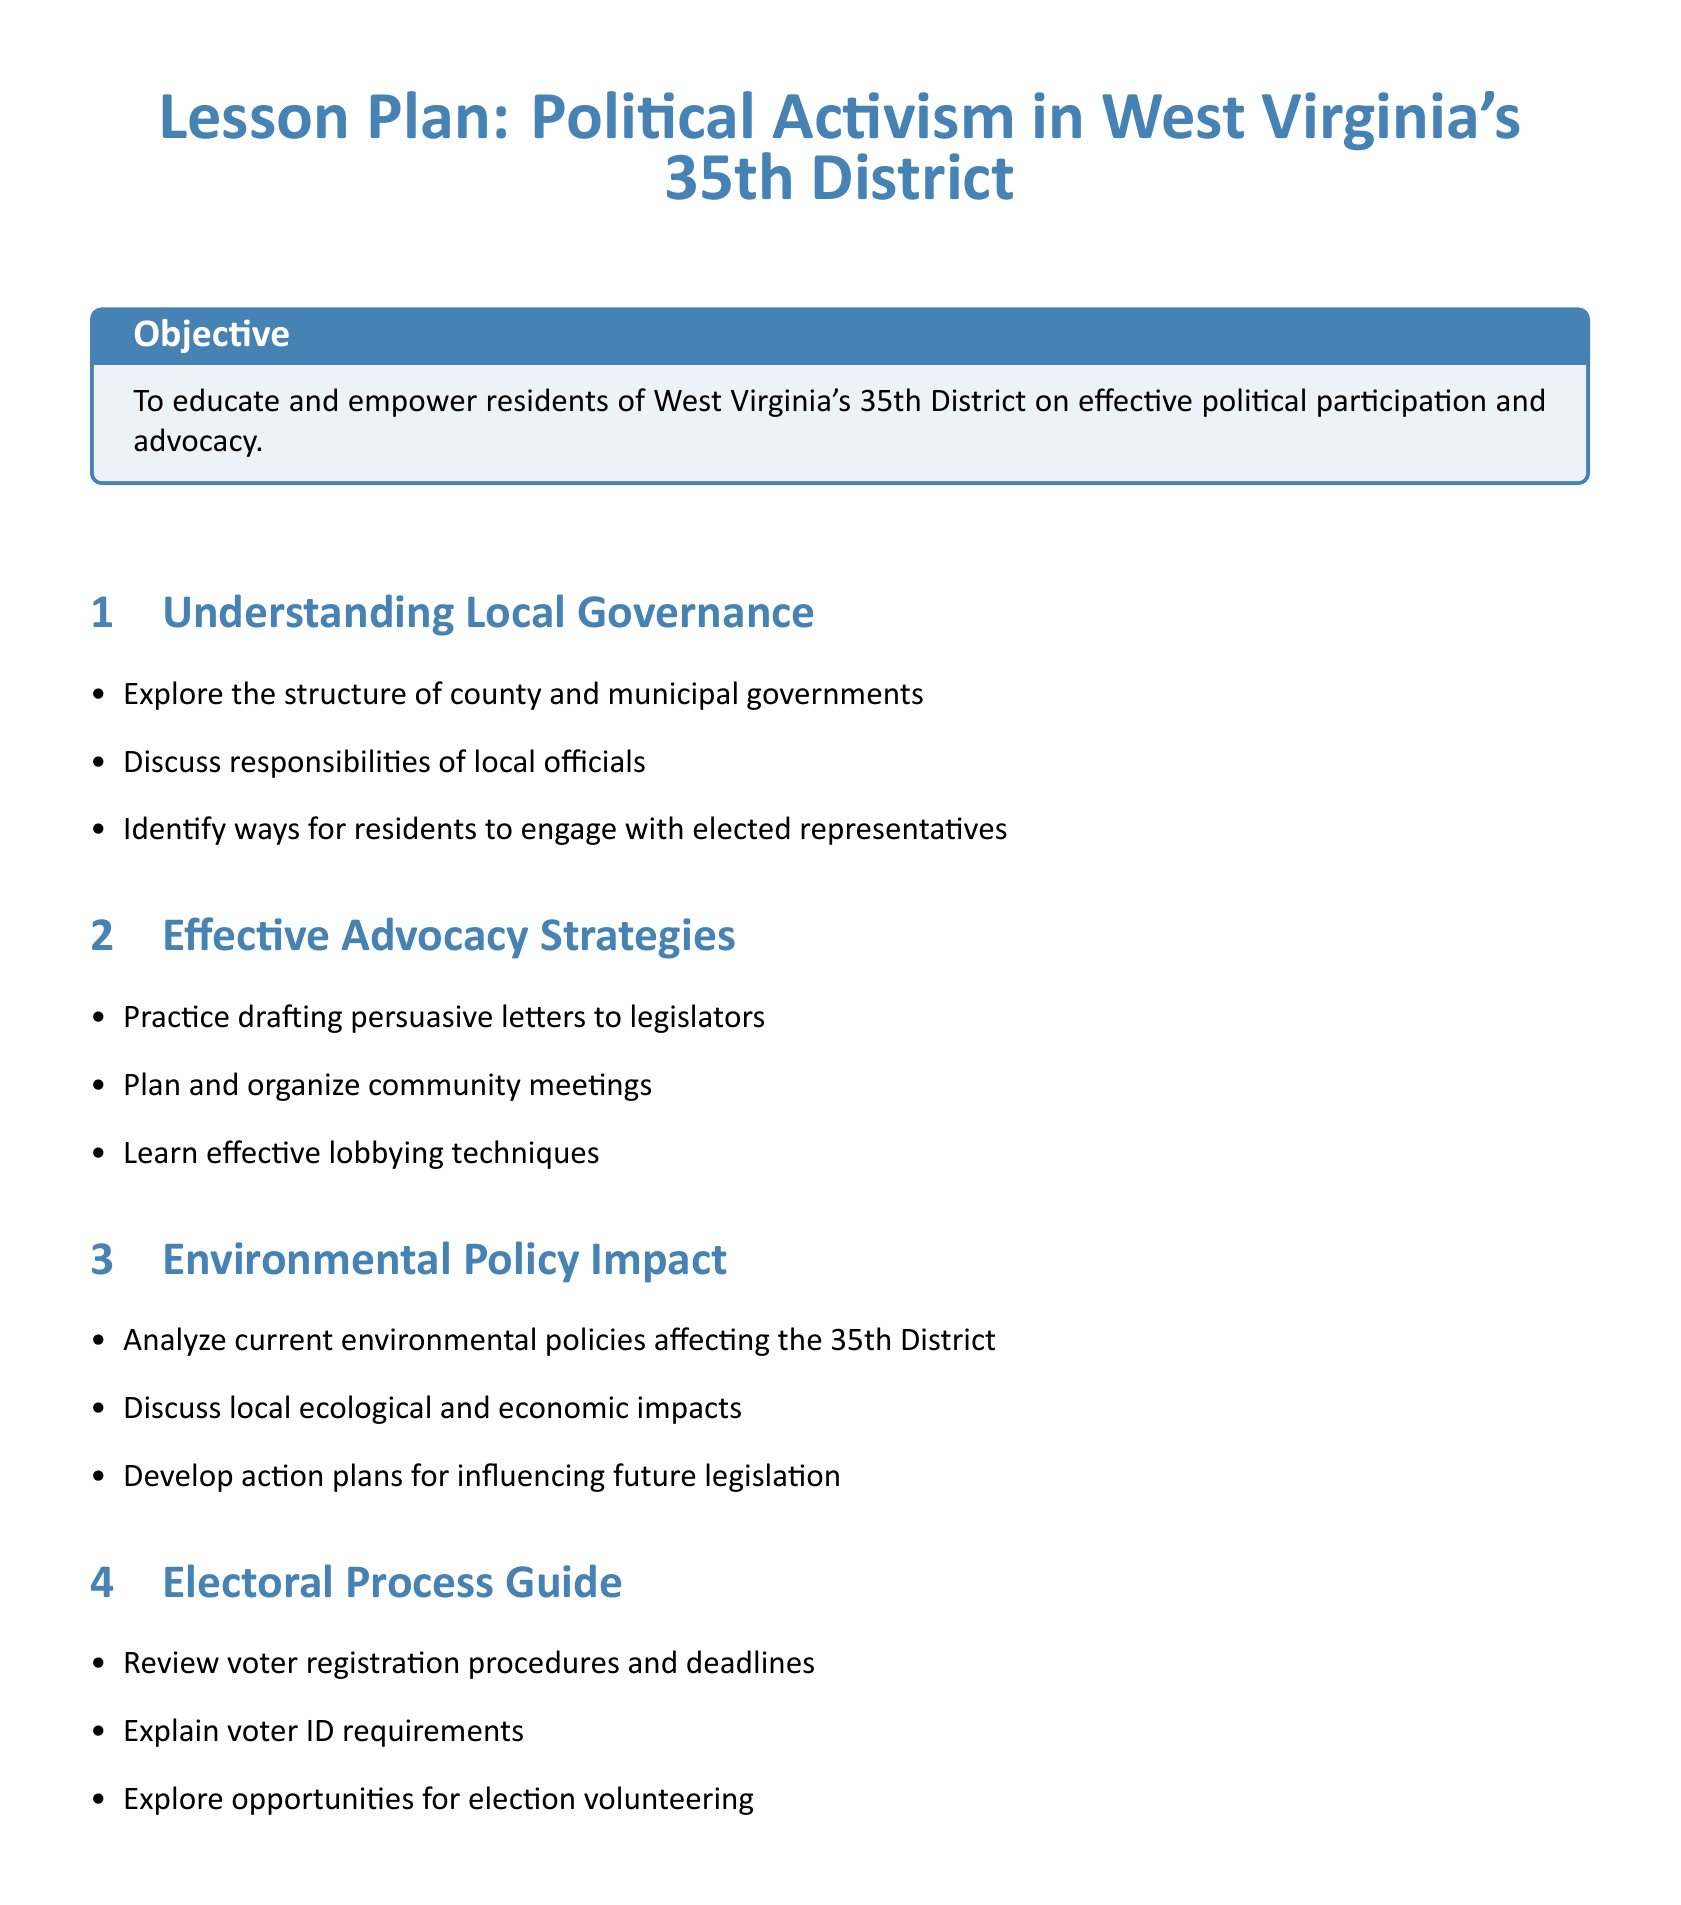What is the objective of the lesson plan? The objective of the lesson plan is to educate and empower residents of West Virginia's 35th District on effective political participation and advocacy.
Answer: To educate and empower residents What section discusses the responsibilities of local officials? The responsibilities of local officials are discussed in the Understanding Local Governance section.
Answer: Understanding Local Governance How many main topics are covered in the lesson plan? The lesson plan covers five main topics.
Answer: Five What type of exercise simulates interactions with local officials? The role-play exercise simulates interactions with local officials.
Answer: Role-play exercises Which organization provides resources for voter registration information? The West Virginia Secretary of State website provides resources for voter registration information.
Answer: West Virginia Secretary of State website What is a key challenge addressed in the Community Health Engagement section? The key public health challenge addressed is health disparities in the district.
Answer: Health disparities Which activity involves drafting letters? The workshop activity involves drafting letters to state legislators on environmental issues.
Answer: Workshop What color is used for the section titles? The color used for the section titles is mountain blue.
Answer: Mountain blue Which government office's contact information is included in the resources? The Kanawha County Clerk's office contact information is included in the resources.
Answer: Kanawha County Clerk's office 